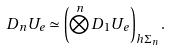<formula> <loc_0><loc_0><loc_500><loc_500>D _ { n } U _ { e } \simeq \left ( \bigotimes ^ { n } D _ { 1 } U _ { e } \right ) _ { h \Sigma _ { n } } .</formula> 